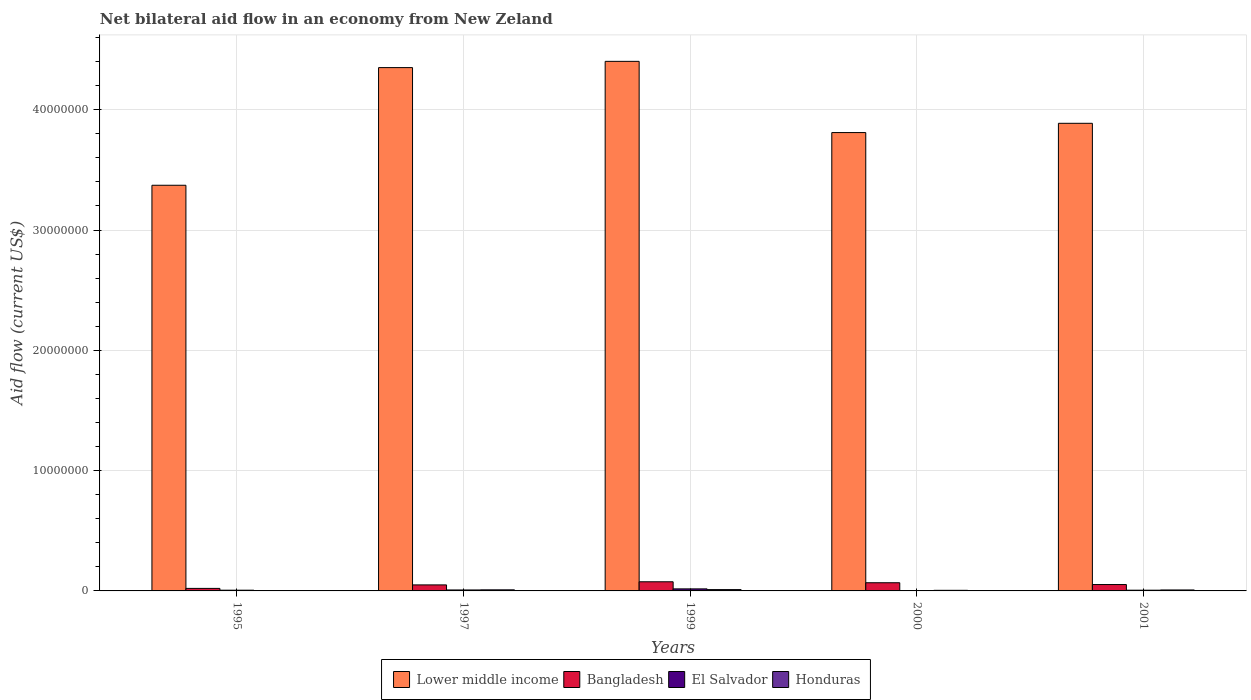How many different coloured bars are there?
Offer a very short reply. 4. How many groups of bars are there?
Provide a succinct answer. 5. Are the number of bars on each tick of the X-axis equal?
Offer a terse response. Yes. How many bars are there on the 1st tick from the left?
Provide a succinct answer. 4. How many bars are there on the 5th tick from the right?
Your answer should be compact. 4. What is the net bilateral aid flow in Lower middle income in 1997?
Make the answer very short. 4.35e+07. Across all years, what is the maximum net bilateral aid flow in Bangladesh?
Provide a succinct answer. 7.60e+05. What is the total net bilateral aid flow in Bangladesh in the graph?
Provide a succinct answer. 2.68e+06. What is the difference between the net bilateral aid flow in Lower middle income in 1995 and that in 2000?
Make the answer very short. -4.38e+06. What is the difference between the net bilateral aid flow in Honduras in 2000 and the net bilateral aid flow in Lower middle income in 1997?
Give a very brief answer. -4.34e+07. What is the average net bilateral aid flow in El Salvador per year?
Offer a very short reply. 7.80e+04. In the year 2000, what is the difference between the net bilateral aid flow in El Salvador and net bilateral aid flow in Lower middle income?
Offer a terse response. -3.81e+07. What is the ratio of the net bilateral aid flow in Honduras in 2000 to that in 2001?
Provide a short and direct response. 0.62. What is the difference between the highest and the lowest net bilateral aid flow in Lower middle income?
Keep it short and to the point. 1.03e+07. In how many years, is the net bilateral aid flow in Lower middle income greater than the average net bilateral aid flow in Lower middle income taken over all years?
Give a very brief answer. 2. Is the sum of the net bilateral aid flow in El Salvador in 2000 and 2001 greater than the maximum net bilateral aid flow in Lower middle income across all years?
Offer a terse response. No. Is it the case that in every year, the sum of the net bilateral aid flow in Honduras and net bilateral aid flow in El Salvador is greater than the sum of net bilateral aid flow in Lower middle income and net bilateral aid flow in Bangladesh?
Keep it short and to the point. No. What does the 2nd bar from the left in 1999 represents?
Provide a succinct answer. Bangladesh. How many bars are there?
Make the answer very short. 20. Are all the bars in the graph horizontal?
Ensure brevity in your answer.  No. How many years are there in the graph?
Your answer should be very brief. 5. What is the difference between two consecutive major ticks on the Y-axis?
Ensure brevity in your answer.  1.00e+07. Where does the legend appear in the graph?
Offer a very short reply. Bottom center. How many legend labels are there?
Your response must be concise. 4. How are the legend labels stacked?
Keep it short and to the point. Horizontal. What is the title of the graph?
Provide a short and direct response. Net bilateral aid flow in an economy from New Zeland. Does "Oman" appear as one of the legend labels in the graph?
Ensure brevity in your answer.  No. What is the label or title of the X-axis?
Provide a succinct answer. Years. What is the Aid flow (current US$) in Lower middle income in 1995?
Give a very brief answer. 3.37e+07. What is the Aid flow (current US$) in Bangladesh in 1995?
Keep it short and to the point. 2.10e+05. What is the Aid flow (current US$) in Lower middle income in 1997?
Keep it short and to the point. 4.35e+07. What is the Aid flow (current US$) in Bangladesh in 1997?
Make the answer very short. 5.00e+05. What is the Aid flow (current US$) of El Salvador in 1997?
Keep it short and to the point. 8.00e+04. What is the Aid flow (current US$) of Lower middle income in 1999?
Ensure brevity in your answer.  4.40e+07. What is the Aid flow (current US$) of Bangladesh in 1999?
Provide a succinct answer. 7.60e+05. What is the Aid flow (current US$) of El Salvador in 1999?
Ensure brevity in your answer.  1.70e+05. What is the Aid flow (current US$) of Lower middle income in 2000?
Ensure brevity in your answer.  3.81e+07. What is the Aid flow (current US$) in Bangladesh in 2000?
Provide a short and direct response. 6.80e+05. What is the Aid flow (current US$) of El Salvador in 2000?
Ensure brevity in your answer.  2.00e+04. What is the Aid flow (current US$) of Lower middle income in 2001?
Your answer should be compact. 3.89e+07. What is the Aid flow (current US$) in Bangladesh in 2001?
Keep it short and to the point. 5.30e+05. What is the Aid flow (current US$) of Honduras in 2001?
Ensure brevity in your answer.  8.00e+04. Across all years, what is the maximum Aid flow (current US$) of Lower middle income?
Provide a short and direct response. 4.40e+07. Across all years, what is the maximum Aid flow (current US$) in Bangladesh?
Provide a short and direct response. 7.60e+05. Across all years, what is the maximum Aid flow (current US$) of El Salvador?
Keep it short and to the point. 1.70e+05. Across all years, what is the minimum Aid flow (current US$) in Lower middle income?
Offer a terse response. 3.37e+07. Across all years, what is the minimum Aid flow (current US$) of El Salvador?
Offer a terse response. 2.00e+04. Across all years, what is the minimum Aid flow (current US$) of Honduras?
Provide a short and direct response. 10000. What is the total Aid flow (current US$) of Lower middle income in the graph?
Provide a succinct answer. 1.98e+08. What is the total Aid flow (current US$) in Bangladesh in the graph?
Keep it short and to the point. 2.68e+06. What is the total Aid flow (current US$) in Honduras in the graph?
Offer a very short reply. 3.40e+05. What is the difference between the Aid flow (current US$) of Lower middle income in 1995 and that in 1997?
Your answer should be very brief. -9.78e+06. What is the difference between the Aid flow (current US$) in Honduras in 1995 and that in 1997?
Offer a very short reply. -8.00e+04. What is the difference between the Aid flow (current US$) in Lower middle income in 1995 and that in 1999?
Offer a very short reply. -1.03e+07. What is the difference between the Aid flow (current US$) of Bangladesh in 1995 and that in 1999?
Your answer should be very brief. -5.50e+05. What is the difference between the Aid flow (current US$) in El Salvador in 1995 and that in 1999?
Your answer should be compact. -1.10e+05. What is the difference between the Aid flow (current US$) of Lower middle income in 1995 and that in 2000?
Your response must be concise. -4.38e+06. What is the difference between the Aid flow (current US$) of Bangladesh in 1995 and that in 2000?
Offer a very short reply. -4.70e+05. What is the difference between the Aid flow (current US$) of El Salvador in 1995 and that in 2000?
Offer a very short reply. 4.00e+04. What is the difference between the Aid flow (current US$) of Honduras in 1995 and that in 2000?
Your answer should be very brief. -4.00e+04. What is the difference between the Aid flow (current US$) in Lower middle income in 1995 and that in 2001?
Give a very brief answer. -5.15e+06. What is the difference between the Aid flow (current US$) of Bangladesh in 1995 and that in 2001?
Your response must be concise. -3.20e+05. What is the difference between the Aid flow (current US$) in Honduras in 1995 and that in 2001?
Your answer should be very brief. -7.00e+04. What is the difference between the Aid flow (current US$) of Lower middle income in 1997 and that in 1999?
Make the answer very short. -5.20e+05. What is the difference between the Aid flow (current US$) in Bangladesh in 1997 and that in 1999?
Your answer should be compact. -2.60e+05. What is the difference between the Aid flow (current US$) in El Salvador in 1997 and that in 1999?
Keep it short and to the point. -9.00e+04. What is the difference between the Aid flow (current US$) in Honduras in 1997 and that in 1999?
Offer a terse response. -2.00e+04. What is the difference between the Aid flow (current US$) in Lower middle income in 1997 and that in 2000?
Provide a short and direct response. 5.40e+06. What is the difference between the Aid flow (current US$) of Honduras in 1997 and that in 2000?
Give a very brief answer. 4.00e+04. What is the difference between the Aid flow (current US$) of Lower middle income in 1997 and that in 2001?
Offer a terse response. 4.63e+06. What is the difference between the Aid flow (current US$) of Lower middle income in 1999 and that in 2000?
Ensure brevity in your answer.  5.92e+06. What is the difference between the Aid flow (current US$) of Honduras in 1999 and that in 2000?
Keep it short and to the point. 6.00e+04. What is the difference between the Aid flow (current US$) of Lower middle income in 1999 and that in 2001?
Provide a short and direct response. 5.15e+06. What is the difference between the Aid flow (current US$) of Honduras in 1999 and that in 2001?
Provide a short and direct response. 3.00e+04. What is the difference between the Aid flow (current US$) of Lower middle income in 2000 and that in 2001?
Offer a terse response. -7.70e+05. What is the difference between the Aid flow (current US$) of El Salvador in 2000 and that in 2001?
Offer a terse response. -4.00e+04. What is the difference between the Aid flow (current US$) in Lower middle income in 1995 and the Aid flow (current US$) in Bangladesh in 1997?
Ensure brevity in your answer.  3.32e+07. What is the difference between the Aid flow (current US$) of Lower middle income in 1995 and the Aid flow (current US$) of El Salvador in 1997?
Ensure brevity in your answer.  3.36e+07. What is the difference between the Aid flow (current US$) in Lower middle income in 1995 and the Aid flow (current US$) in Honduras in 1997?
Ensure brevity in your answer.  3.36e+07. What is the difference between the Aid flow (current US$) of Bangladesh in 1995 and the Aid flow (current US$) of El Salvador in 1997?
Make the answer very short. 1.30e+05. What is the difference between the Aid flow (current US$) of Bangladesh in 1995 and the Aid flow (current US$) of Honduras in 1997?
Your response must be concise. 1.20e+05. What is the difference between the Aid flow (current US$) in Lower middle income in 1995 and the Aid flow (current US$) in Bangladesh in 1999?
Give a very brief answer. 3.30e+07. What is the difference between the Aid flow (current US$) in Lower middle income in 1995 and the Aid flow (current US$) in El Salvador in 1999?
Ensure brevity in your answer.  3.36e+07. What is the difference between the Aid flow (current US$) of Lower middle income in 1995 and the Aid flow (current US$) of Honduras in 1999?
Offer a terse response. 3.36e+07. What is the difference between the Aid flow (current US$) in Lower middle income in 1995 and the Aid flow (current US$) in Bangladesh in 2000?
Give a very brief answer. 3.30e+07. What is the difference between the Aid flow (current US$) in Lower middle income in 1995 and the Aid flow (current US$) in El Salvador in 2000?
Make the answer very short. 3.37e+07. What is the difference between the Aid flow (current US$) of Lower middle income in 1995 and the Aid flow (current US$) of Honduras in 2000?
Provide a short and direct response. 3.37e+07. What is the difference between the Aid flow (current US$) in Bangladesh in 1995 and the Aid flow (current US$) in El Salvador in 2000?
Make the answer very short. 1.90e+05. What is the difference between the Aid flow (current US$) of Bangladesh in 1995 and the Aid flow (current US$) of Honduras in 2000?
Provide a succinct answer. 1.60e+05. What is the difference between the Aid flow (current US$) in Lower middle income in 1995 and the Aid flow (current US$) in Bangladesh in 2001?
Provide a succinct answer. 3.32e+07. What is the difference between the Aid flow (current US$) of Lower middle income in 1995 and the Aid flow (current US$) of El Salvador in 2001?
Your answer should be compact. 3.37e+07. What is the difference between the Aid flow (current US$) of Lower middle income in 1995 and the Aid flow (current US$) of Honduras in 2001?
Offer a very short reply. 3.36e+07. What is the difference between the Aid flow (current US$) of Bangladesh in 1995 and the Aid flow (current US$) of El Salvador in 2001?
Your answer should be very brief. 1.50e+05. What is the difference between the Aid flow (current US$) of Bangladesh in 1995 and the Aid flow (current US$) of Honduras in 2001?
Your response must be concise. 1.30e+05. What is the difference between the Aid flow (current US$) in Lower middle income in 1997 and the Aid flow (current US$) in Bangladesh in 1999?
Your answer should be very brief. 4.27e+07. What is the difference between the Aid flow (current US$) in Lower middle income in 1997 and the Aid flow (current US$) in El Salvador in 1999?
Your response must be concise. 4.33e+07. What is the difference between the Aid flow (current US$) in Lower middle income in 1997 and the Aid flow (current US$) in Honduras in 1999?
Provide a succinct answer. 4.34e+07. What is the difference between the Aid flow (current US$) of Bangladesh in 1997 and the Aid flow (current US$) of El Salvador in 1999?
Provide a short and direct response. 3.30e+05. What is the difference between the Aid flow (current US$) in El Salvador in 1997 and the Aid flow (current US$) in Honduras in 1999?
Give a very brief answer. -3.00e+04. What is the difference between the Aid flow (current US$) in Lower middle income in 1997 and the Aid flow (current US$) in Bangladesh in 2000?
Offer a terse response. 4.28e+07. What is the difference between the Aid flow (current US$) of Lower middle income in 1997 and the Aid flow (current US$) of El Salvador in 2000?
Offer a terse response. 4.35e+07. What is the difference between the Aid flow (current US$) of Lower middle income in 1997 and the Aid flow (current US$) of Honduras in 2000?
Give a very brief answer. 4.34e+07. What is the difference between the Aid flow (current US$) in Bangladesh in 1997 and the Aid flow (current US$) in Honduras in 2000?
Offer a very short reply. 4.50e+05. What is the difference between the Aid flow (current US$) in El Salvador in 1997 and the Aid flow (current US$) in Honduras in 2000?
Make the answer very short. 3.00e+04. What is the difference between the Aid flow (current US$) in Lower middle income in 1997 and the Aid flow (current US$) in Bangladesh in 2001?
Offer a terse response. 4.30e+07. What is the difference between the Aid flow (current US$) in Lower middle income in 1997 and the Aid flow (current US$) in El Salvador in 2001?
Provide a short and direct response. 4.34e+07. What is the difference between the Aid flow (current US$) of Lower middle income in 1997 and the Aid flow (current US$) of Honduras in 2001?
Ensure brevity in your answer.  4.34e+07. What is the difference between the Aid flow (current US$) of Bangladesh in 1997 and the Aid flow (current US$) of El Salvador in 2001?
Provide a succinct answer. 4.40e+05. What is the difference between the Aid flow (current US$) of Bangladesh in 1997 and the Aid flow (current US$) of Honduras in 2001?
Make the answer very short. 4.20e+05. What is the difference between the Aid flow (current US$) in El Salvador in 1997 and the Aid flow (current US$) in Honduras in 2001?
Keep it short and to the point. 0. What is the difference between the Aid flow (current US$) in Lower middle income in 1999 and the Aid flow (current US$) in Bangladesh in 2000?
Make the answer very short. 4.33e+07. What is the difference between the Aid flow (current US$) of Lower middle income in 1999 and the Aid flow (current US$) of El Salvador in 2000?
Provide a short and direct response. 4.40e+07. What is the difference between the Aid flow (current US$) of Lower middle income in 1999 and the Aid flow (current US$) of Honduras in 2000?
Your answer should be very brief. 4.40e+07. What is the difference between the Aid flow (current US$) of Bangladesh in 1999 and the Aid flow (current US$) of El Salvador in 2000?
Your answer should be very brief. 7.40e+05. What is the difference between the Aid flow (current US$) of Bangladesh in 1999 and the Aid flow (current US$) of Honduras in 2000?
Your answer should be compact. 7.10e+05. What is the difference between the Aid flow (current US$) in El Salvador in 1999 and the Aid flow (current US$) in Honduras in 2000?
Your answer should be compact. 1.20e+05. What is the difference between the Aid flow (current US$) in Lower middle income in 1999 and the Aid flow (current US$) in Bangladesh in 2001?
Your response must be concise. 4.35e+07. What is the difference between the Aid flow (current US$) of Lower middle income in 1999 and the Aid flow (current US$) of El Salvador in 2001?
Ensure brevity in your answer.  4.40e+07. What is the difference between the Aid flow (current US$) of Lower middle income in 1999 and the Aid flow (current US$) of Honduras in 2001?
Give a very brief answer. 4.39e+07. What is the difference between the Aid flow (current US$) in Bangladesh in 1999 and the Aid flow (current US$) in El Salvador in 2001?
Your response must be concise. 7.00e+05. What is the difference between the Aid flow (current US$) in Bangladesh in 1999 and the Aid flow (current US$) in Honduras in 2001?
Offer a terse response. 6.80e+05. What is the difference between the Aid flow (current US$) in El Salvador in 1999 and the Aid flow (current US$) in Honduras in 2001?
Ensure brevity in your answer.  9.00e+04. What is the difference between the Aid flow (current US$) in Lower middle income in 2000 and the Aid flow (current US$) in Bangladesh in 2001?
Offer a very short reply. 3.76e+07. What is the difference between the Aid flow (current US$) of Lower middle income in 2000 and the Aid flow (current US$) of El Salvador in 2001?
Give a very brief answer. 3.80e+07. What is the difference between the Aid flow (current US$) of Lower middle income in 2000 and the Aid flow (current US$) of Honduras in 2001?
Your answer should be compact. 3.80e+07. What is the difference between the Aid flow (current US$) in Bangladesh in 2000 and the Aid flow (current US$) in El Salvador in 2001?
Offer a terse response. 6.20e+05. What is the difference between the Aid flow (current US$) in El Salvador in 2000 and the Aid flow (current US$) in Honduras in 2001?
Give a very brief answer. -6.00e+04. What is the average Aid flow (current US$) of Lower middle income per year?
Offer a terse response. 3.96e+07. What is the average Aid flow (current US$) of Bangladesh per year?
Give a very brief answer. 5.36e+05. What is the average Aid flow (current US$) in El Salvador per year?
Give a very brief answer. 7.80e+04. What is the average Aid flow (current US$) of Honduras per year?
Offer a very short reply. 6.80e+04. In the year 1995, what is the difference between the Aid flow (current US$) of Lower middle income and Aid flow (current US$) of Bangladesh?
Offer a very short reply. 3.35e+07. In the year 1995, what is the difference between the Aid flow (current US$) in Lower middle income and Aid flow (current US$) in El Salvador?
Your answer should be very brief. 3.37e+07. In the year 1995, what is the difference between the Aid flow (current US$) of Lower middle income and Aid flow (current US$) of Honduras?
Your answer should be compact. 3.37e+07. In the year 1995, what is the difference between the Aid flow (current US$) of Bangladesh and Aid flow (current US$) of El Salvador?
Your answer should be very brief. 1.50e+05. In the year 1995, what is the difference between the Aid flow (current US$) in Bangladesh and Aid flow (current US$) in Honduras?
Provide a succinct answer. 2.00e+05. In the year 1995, what is the difference between the Aid flow (current US$) in El Salvador and Aid flow (current US$) in Honduras?
Provide a short and direct response. 5.00e+04. In the year 1997, what is the difference between the Aid flow (current US$) of Lower middle income and Aid flow (current US$) of Bangladesh?
Make the answer very short. 4.30e+07. In the year 1997, what is the difference between the Aid flow (current US$) of Lower middle income and Aid flow (current US$) of El Salvador?
Offer a terse response. 4.34e+07. In the year 1997, what is the difference between the Aid flow (current US$) of Lower middle income and Aid flow (current US$) of Honduras?
Your answer should be very brief. 4.34e+07. In the year 1999, what is the difference between the Aid flow (current US$) in Lower middle income and Aid flow (current US$) in Bangladesh?
Make the answer very short. 4.33e+07. In the year 1999, what is the difference between the Aid flow (current US$) of Lower middle income and Aid flow (current US$) of El Salvador?
Your response must be concise. 4.38e+07. In the year 1999, what is the difference between the Aid flow (current US$) in Lower middle income and Aid flow (current US$) in Honduras?
Offer a terse response. 4.39e+07. In the year 1999, what is the difference between the Aid flow (current US$) in Bangladesh and Aid flow (current US$) in El Salvador?
Your answer should be compact. 5.90e+05. In the year 1999, what is the difference between the Aid flow (current US$) in Bangladesh and Aid flow (current US$) in Honduras?
Your answer should be very brief. 6.50e+05. In the year 1999, what is the difference between the Aid flow (current US$) of El Salvador and Aid flow (current US$) of Honduras?
Your answer should be compact. 6.00e+04. In the year 2000, what is the difference between the Aid flow (current US$) in Lower middle income and Aid flow (current US$) in Bangladesh?
Keep it short and to the point. 3.74e+07. In the year 2000, what is the difference between the Aid flow (current US$) in Lower middle income and Aid flow (current US$) in El Salvador?
Your response must be concise. 3.81e+07. In the year 2000, what is the difference between the Aid flow (current US$) in Lower middle income and Aid flow (current US$) in Honduras?
Ensure brevity in your answer.  3.80e+07. In the year 2000, what is the difference between the Aid flow (current US$) in Bangladesh and Aid flow (current US$) in Honduras?
Your answer should be very brief. 6.30e+05. In the year 2001, what is the difference between the Aid flow (current US$) in Lower middle income and Aid flow (current US$) in Bangladesh?
Give a very brief answer. 3.83e+07. In the year 2001, what is the difference between the Aid flow (current US$) in Lower middle income and Aid flow (current US$) in El Salvador?
Keep it short and to the point. 3.88e+07. In the year 2001, what is the difference between the Aid flow (current US$) in Lower middle income and Aid flow (current US$) in Honduras?
Offer a terse response. 3.88e+07. In the year 2001, what is the difference between the Aid flow (current US$) of Bangladesh and Aid flow (current US$) of Honduras?
Keep it short and to the point. 4.50e+05. What is the ratio of the Aid flow (current US$) in Lower middle income in 1995 to that in 1997?
Keep it short and to the point. 0.78. What is the ratio of the Aid flow (current US$) of Bangladesh in 1995 to that in 1997?
Give a very brief answer. 0.42. What is the ratio of the Aid flow (current US$) of Lower middle income in 1995 to that in 1999?
Provide a succinct answer. 0.77. What is the ratio of the Aid flow (current US$) in Bangladesh in 1995 to that in 1999?
Keep it short and to the point. 0.28. What is the ratio of the Aid flow (current US$) of El Salvador in 1995 to that in 1999?
Give a very brief answer. 0.35. What is the ratio of the Aid flow (current US$) in Honduras in 1995 to that in 1999?
Your response must be concise. 0.09. What is the ratio of the Aid flow (current US$) of Lower middle income in 1995 to that in 2000?
Offer a terse response. 0.89. What is the ratio of the Aid flow (current US$) of Bangladesh in 1995 to that in 2000?
Your answer should be compact. 0.31. What is the ratio of the Aid flow (current US$) in Honduras in 1995 to that in 2000?
Your answer should be very brief. 0.2. What is the ratio of the Aid flow (current US$) of Lower middle income in 1995 to that in 2001?
Ensure brevity in your answer.  0.87. What is the ratio of the Aid flow (current US$) of Bangladesh in 1995 to that in 2001?
Give a very brief answer. 0.4. What is the ratio of the Aid flow (current US$) of Bangladesh in 1997 to that in 1999?
Your answer should be compact. 0.66. What is the ratio of the Aid flow (current US$) in El Salvador in 1997 to that in 1999?
Your response must be concise. 0.47. What is the ratio of the Aid flow (current US$) in Honduras in 1997 to that in 1999?
Offer a terse response. 0.82. What is the ratio of the Aid flow (current US$) of Lower middle income in 1997 to that in 2000?
Offer a very short reply. 1.14. What is the ratio of the Aid flow (current US$) in Bangladesh in 1997 to that in 2000?
Ensure brevity in your answer.  0.74. What is the ratio of the Aid flow (current US$) in El Salvador in 1997 to that in 2000?
Make the answer very short. 4. What is the ratio of the Aid flow (current US$) of Lower middle income in 1997 to that in 2001?
Make the answer very short. 1.12. What is the ratio of the Aid flow (current US$) of Bangladesh in 1997 to that in 2001?
Make the answer very short. 0.94. What is the ratio of the Aid flow (current US$) of Lower middle income in 1999 to that in 2000?
Offer a very short reply. 1.16. What is the ratio of the Aid flow (current US$) of Bangladesh in 1999 to that in 2000?
Give a very brief answer. 1.12. What is the ratio of the Aid flow (current US$) of El Salvador in 1999 to that in 2000?
Ensure brevity in your answer.  8.5. What is the ratio of the Aid flow (current US$) of Honduras in 1999 to that in 2000?
Offer a very short reply. 2.2. What is the ratio of the Aid flow (current US$) in Lower middle income in 1999 to that in 2001?
Your response must be concise. 1.13. What is the ratio of the Aid flow (current US$) of Bangladesh in 1999 to that in 2001?
Your answer should be compact. 1.43. What is the ratio of the Aid flow (current US$) in El Salvador in 1999 to that in 2001?
Provide a succinct answer. 2.83. What is the ratio of the Aid flow (current US$) of Honduras in 1999 to that in 2001?
Your answer should be very brief. 1.38. What is the ratio of the Aid flow (current US$) of Lower middle income in 2000 to that in 2001?
Your answer should be compact. 0.98. What is the ratio of the Aid flow (current US$) in Bangladesh in 2000 to that in 2001?
Your answer should be compact. 1.28. What is the ratio of the Aid flow (current US$) of El Salvador in 2000 to that in 2001?
Offer a very short reply. 0.33. What is the difference between the highest and the second highest Aid flow (current US$) in Lower middle income?
Offer a very short reply. 5.20e+05. What is the difference between the highest and the second highest Aid flow (current US$) in Honduras?
Offer a very short reply. 2.00e+04. What is the difference between the highest and the lowest Aid flow (current US$) of Lower middle income?
Your answer should be compact. 1.03e+07. What is the difference between the highest and the lowest Aid flow (current US$) of Bangladesh?
Your answer should be compact. 5.50e+05. What is the difference between the highest and the lowest Aid flow (current US$) of Honduras?
Your answer should be compact. 1.00e+05. 